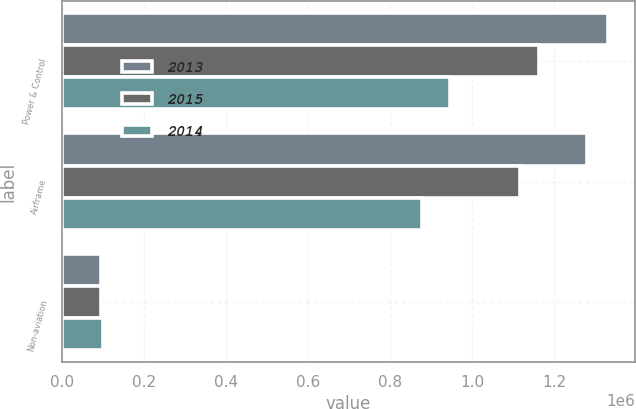Convert chart. <chart><loc_0><loc_0><loc_500><loc_500><stacked_bar_chart><ecel><fcel>Power & Control<fcel>Airframe<fcel>Non-aviation<nl><fcel>2013<fcel>1.33014e+06<fcel>1.28071e+06<fcel>96274<nl><fcel>2015<fcel>1.16181e+06<fcel>1.11559e+06<fcel>95504<nl><fcel>2014<fcel>946587<fcel>877174<fcel>100639<nl></chart> 